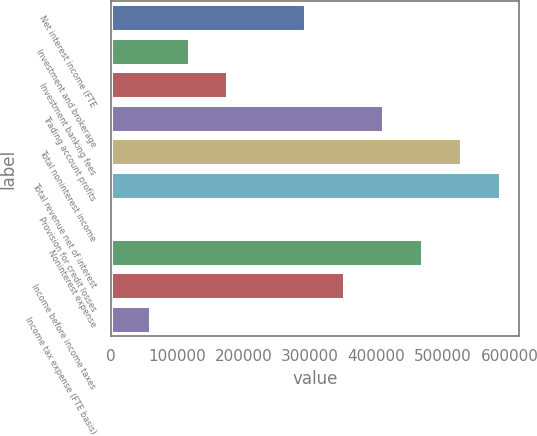<chart> <loc_0><loc_0><loc_500><loc_500><bar_chart><fcel>Net interest income (FTE<fcel>Investment and brokerage<fcel>Investment banking fees<fcel>Trading account profits<fcel>Total noninterest income<fcel>Total revenue net of interest<fcel>Provision for credit losses<fcel>Noninterest expense<fcel>Income before income taxes<fcel>Income tax expense (FTE basis)<nl><fcel>292686<fcel>117093<fcel>175624<fcel>409749<fcel>526811<fcel>585342<fcel>31<fcel>468280<fcel>351218<fcel>58562.1<nl></chart> 